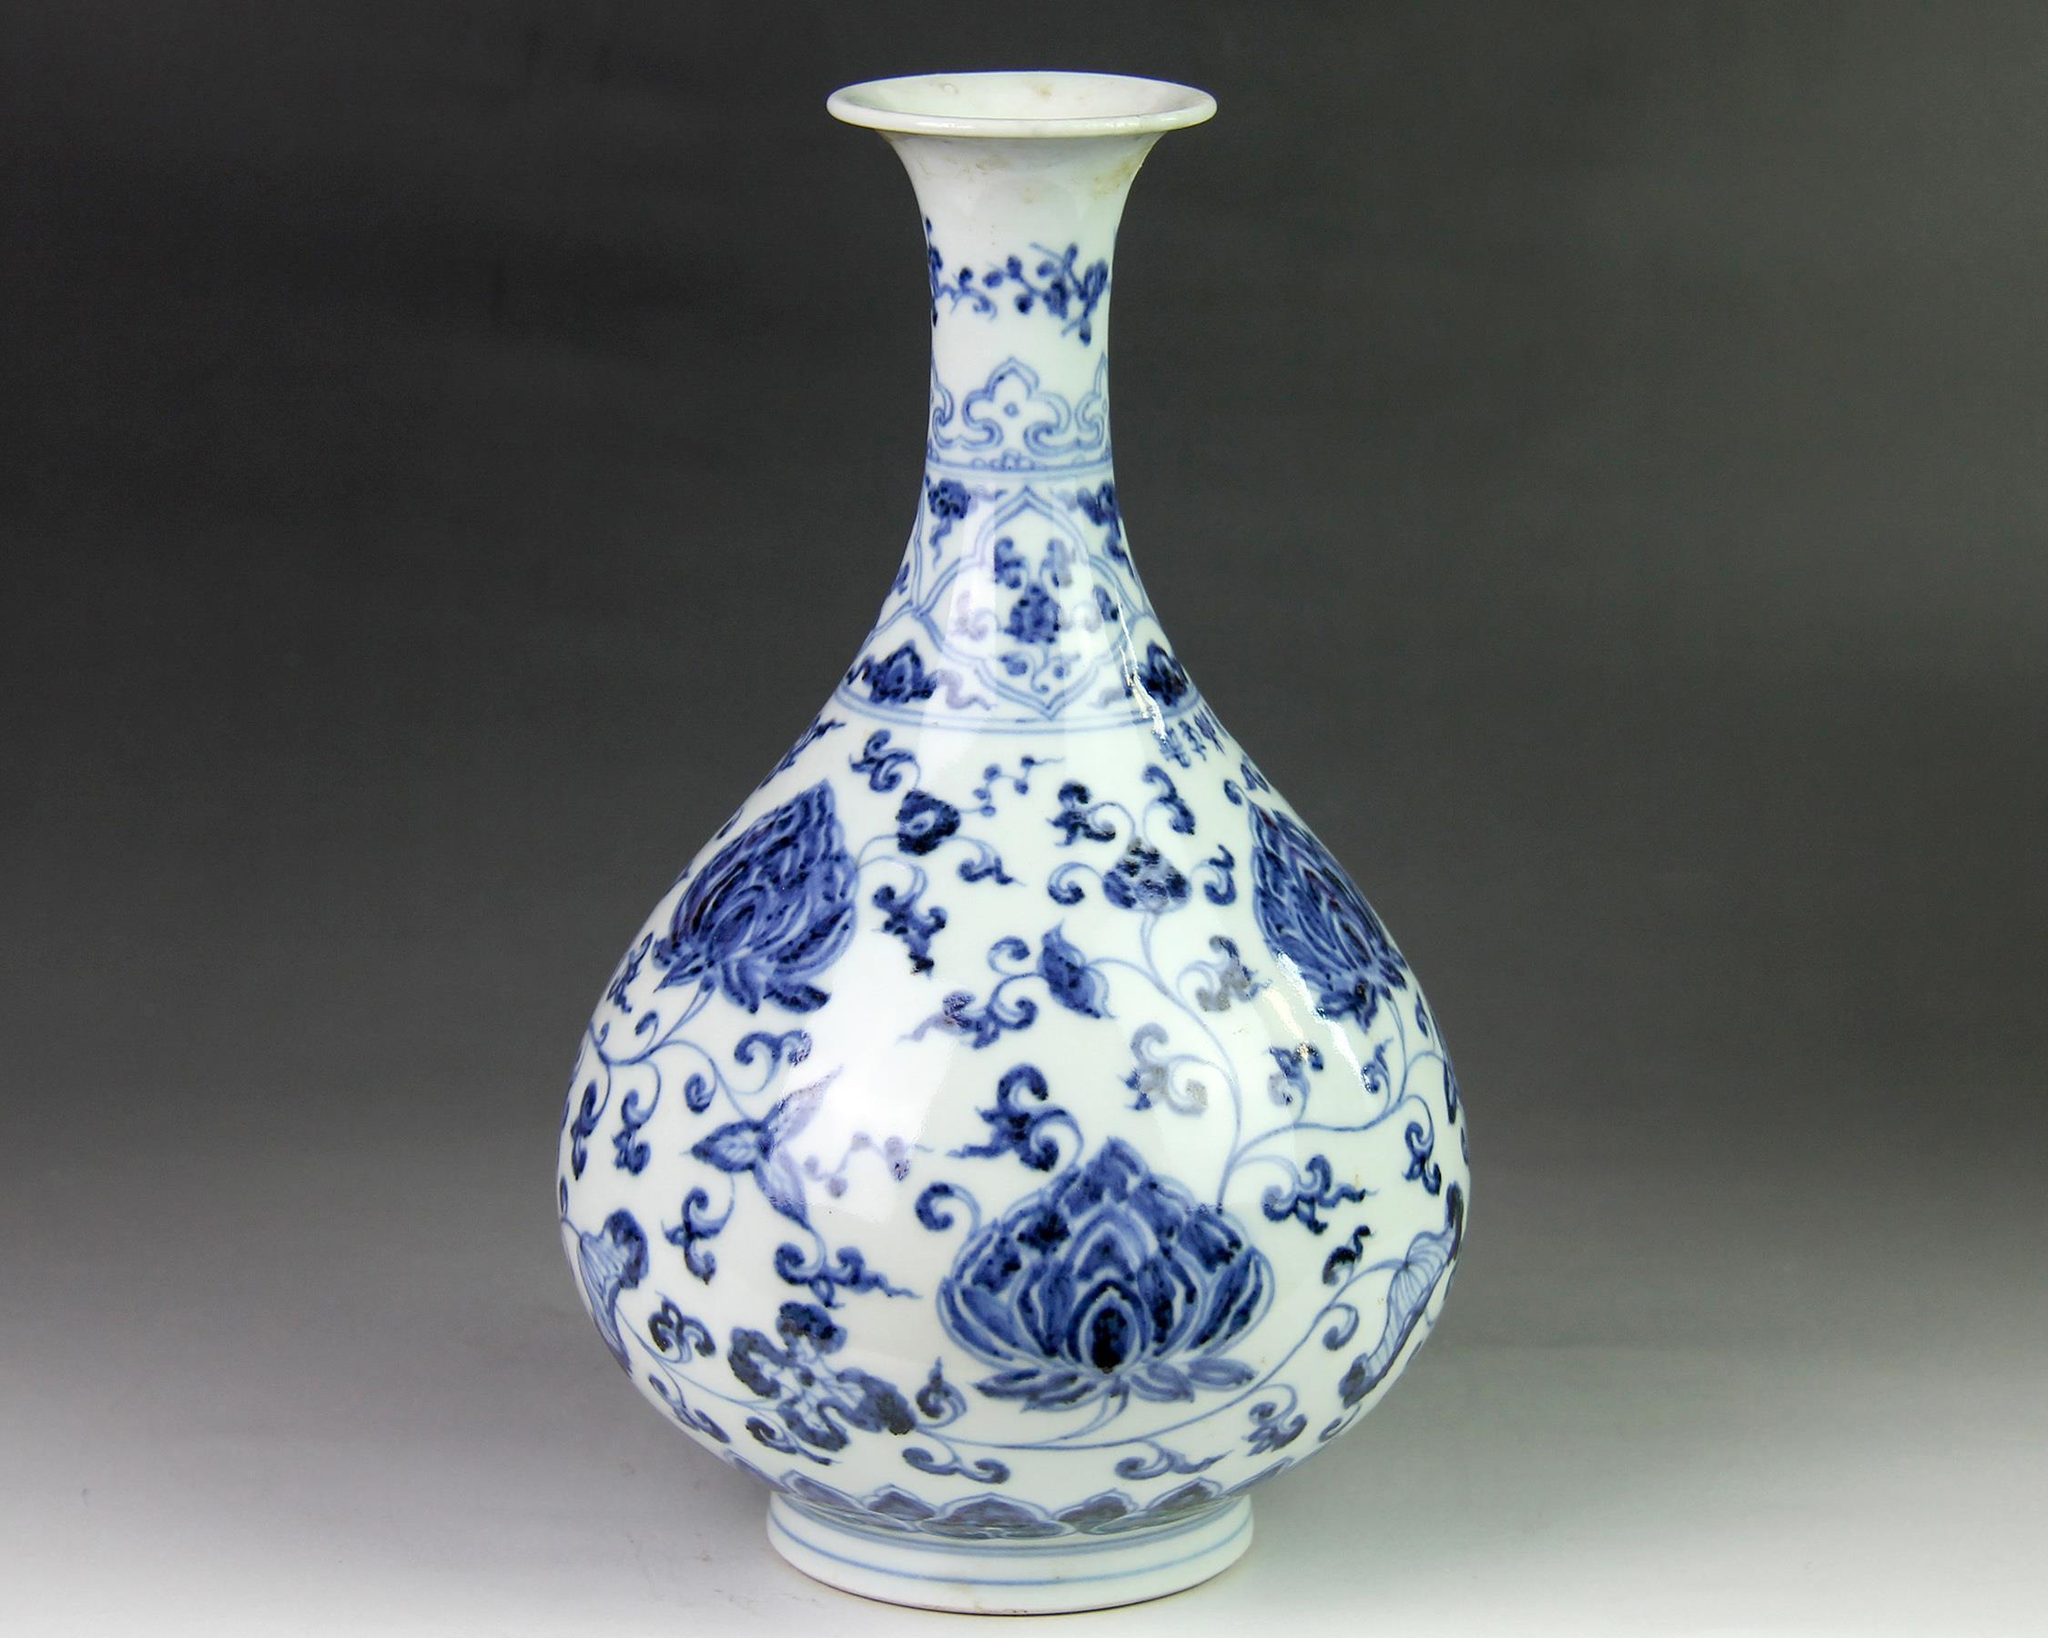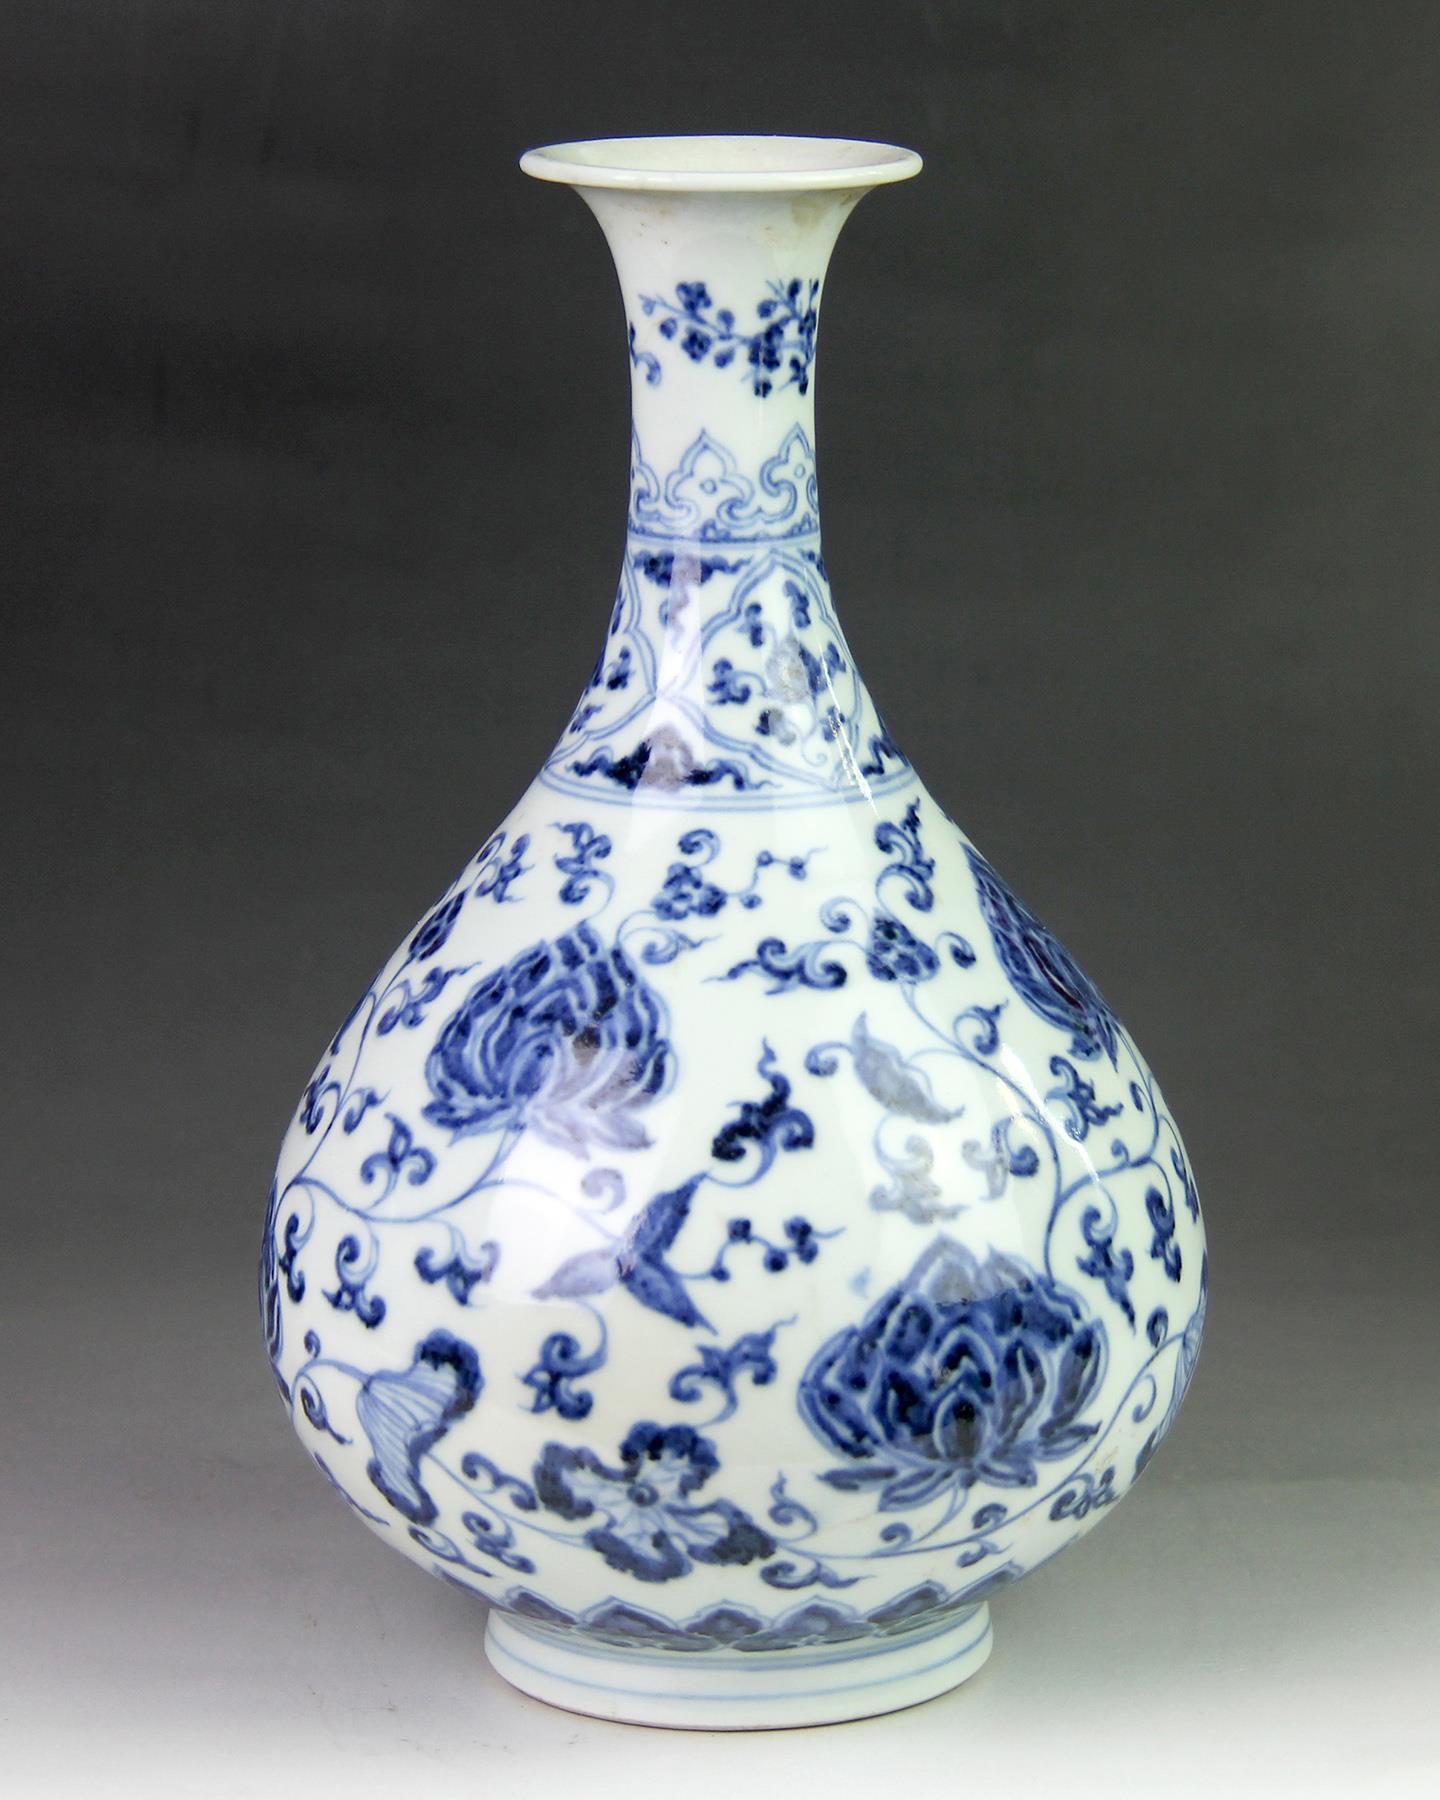The first image is the image on the left, the second image is the image on the right. Assess this claim about the two images: "The vases in the left and right images do not have the same shape, and at least one vase features a dragon-like creature on it.". Correct or not? Answer yes or no. No. The first image is the image on the left, the second image is the image on the right. For the images displayed, is the sentence "One vase has a bulge in the stem." factually correct? Answer yes or no. No. 